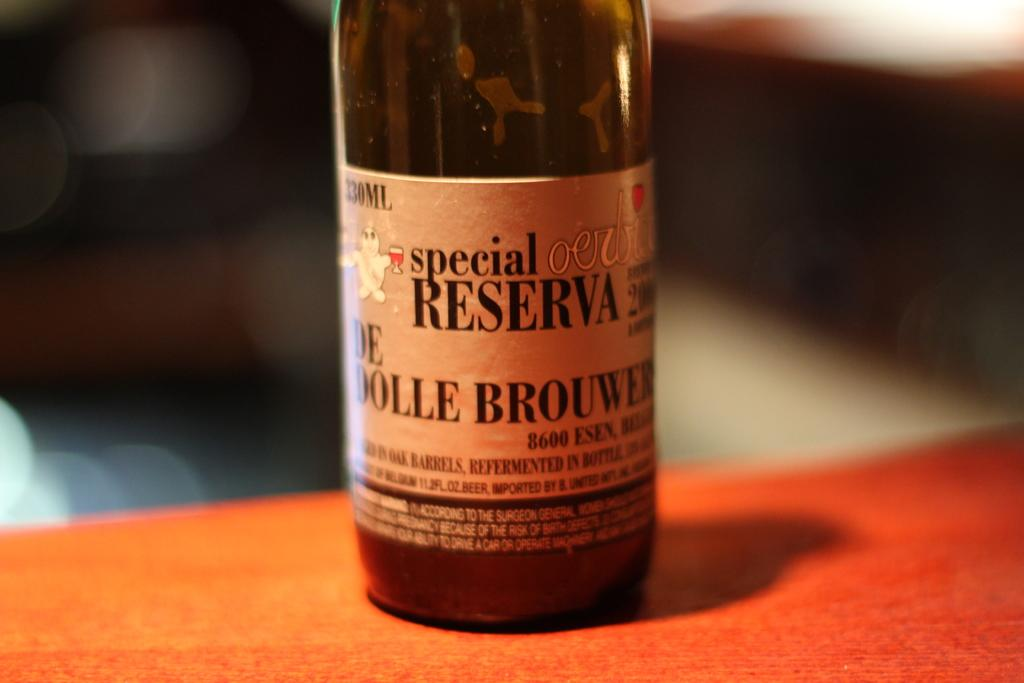<image>
Give a short and clear explanation of the subsequent image. A bottle of Special Reserva beer sits on the table 